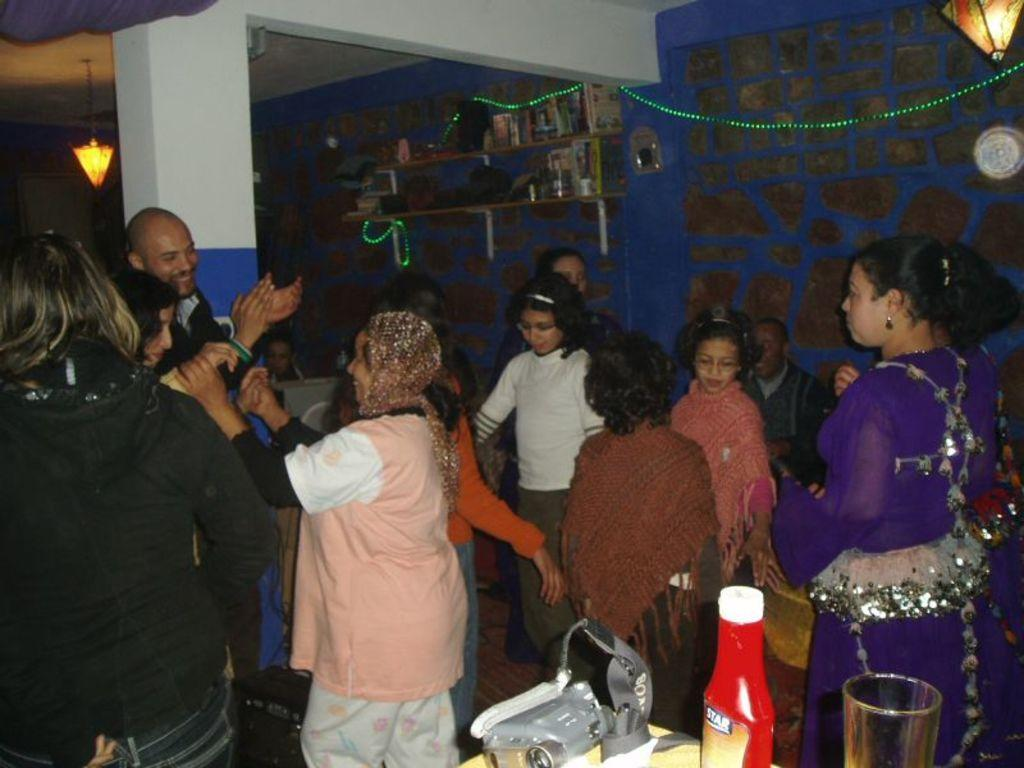Who or what is present in the image? There are people in the image. What objects can be seen on a table in the image? There is a bottle and a glass on a table in the image. What can be seen in the background of the image? There is a wall and lights in the background of the image. How many objects are on the table in the image? There are two objects on the table in the image: a bottle and a glass. What type of dust can be seen on the skate in the image? There is no skate or dust present in the image. What activity are the people engaged in, as seen in the image? The provided facts do not give information about the activity the people are engaged in. 